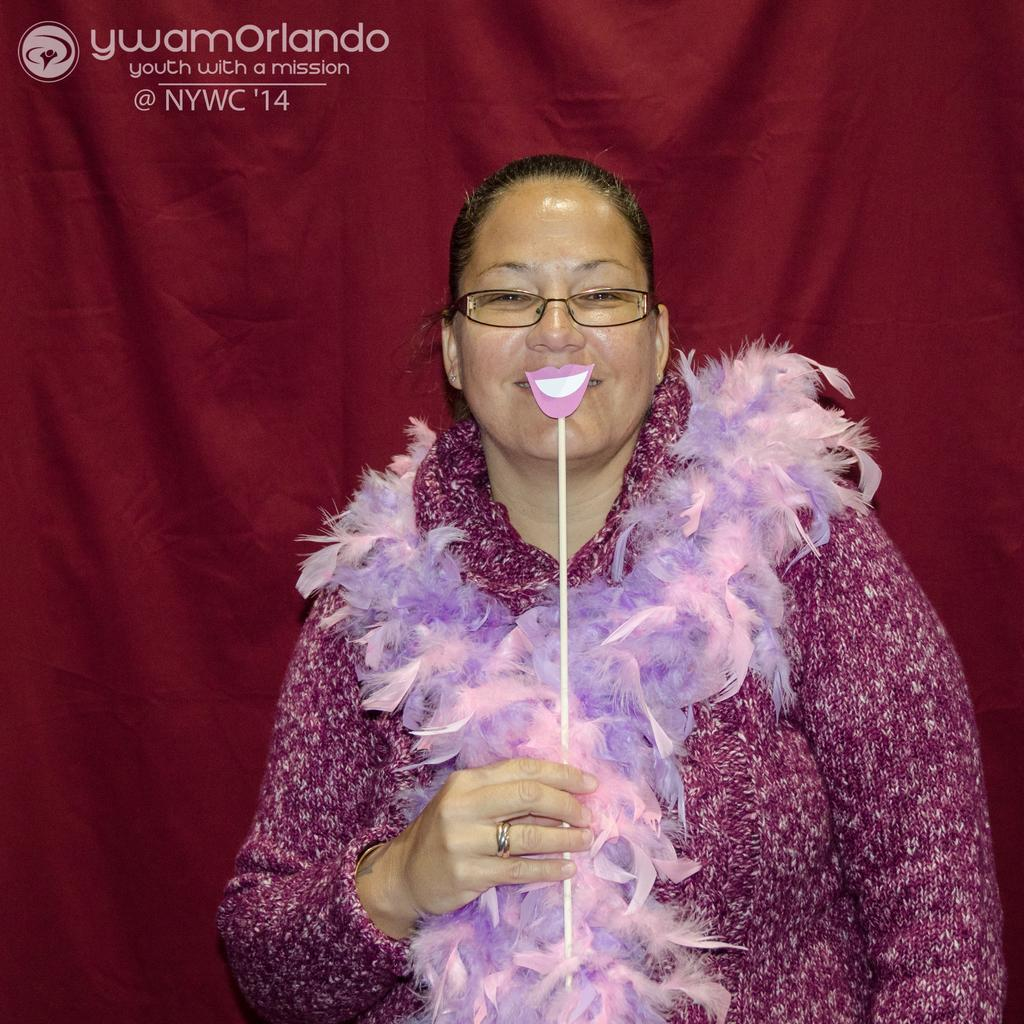Who is present in the image? There is a woman in the image. What is the woman doing in the image? The woman is standing in the image. What object is the woman holding in the image? The woman is holding a stick in the image. What type of covering is visible in the image? There is a curtain visible in the image. What type of worm can be seen crawling on the woman's arm in the image? There is no worm present in the image; the woman is holding a stick. 